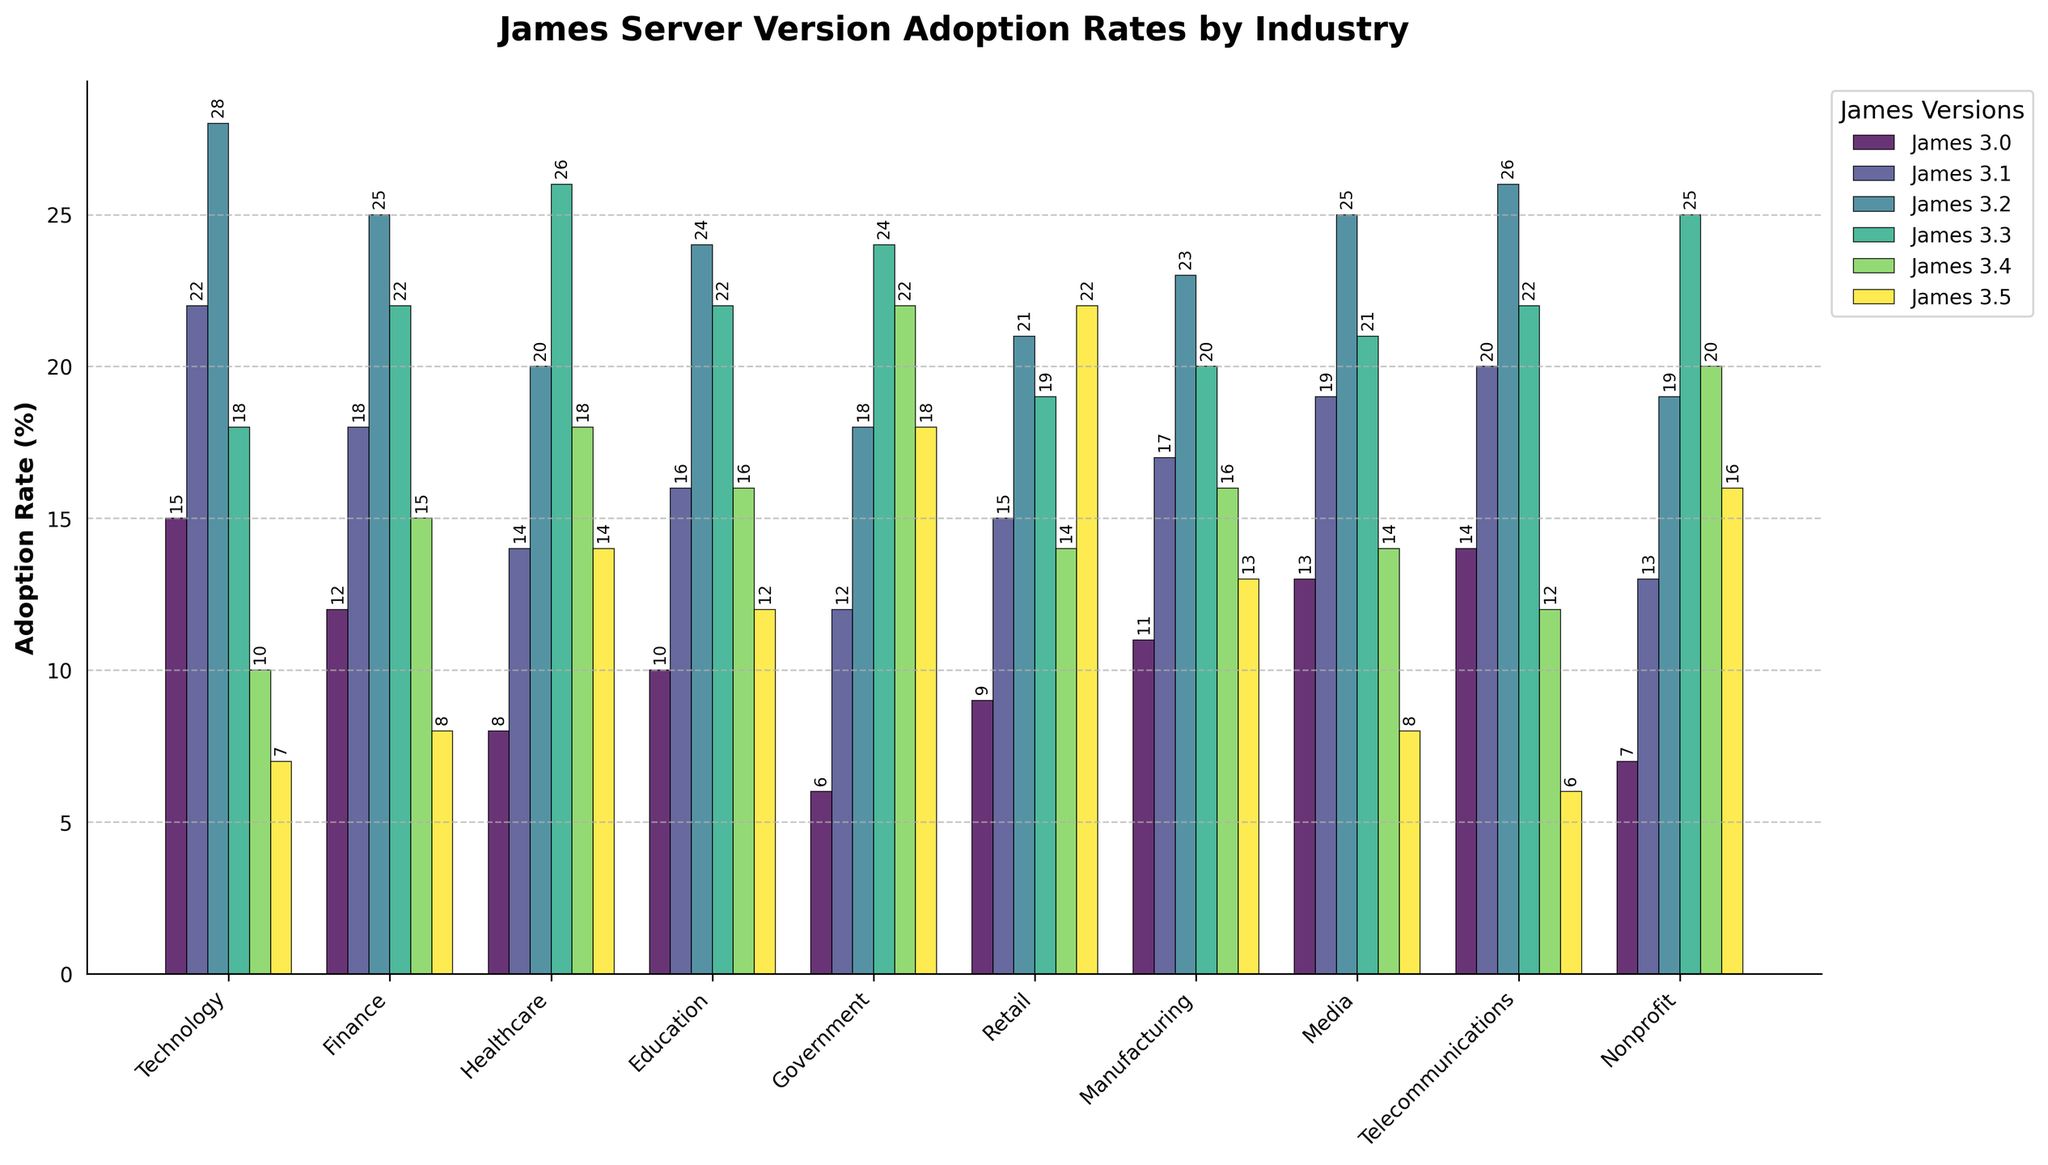Which industry has the highest adoption rate for James 3.2? Look for the highest bar in the group corresponding to James 3.2 and note the industry label beneath it.
Answer: Media What's the difference in the adoption rates of James 3.0 and James 3.4 in the Healthcare sector? Look at the bar heights for James 3.0 and James 3.4 in the Healthcare sector and calculate the difference: 18 - 8.
Answer: 10 Which two industries have the most similar adoption rates for James 3.1? Compare the heights of the bars for James 3.1 across all industries and identify the two closest values: Technology (22) and Telecommunications (20).
Answer: Technology and Telecommunications What is the average adoption rate of James 3.3 across all industries? Sum the adoption rates of James 3.3 across all industries and divide by the number of industries: (18 + 22 + 26 + 22 + 24 + 19 + 20 + 21 + 22 + 25) / 10.
Answer: 21.9 Is the adoption rate of James 3.5 in the Education sector higher or lower than in the Government sector? Compare the bar heights for James 3.5 in Education (12) and Government (18).
Answer: Lower How many industries have an adoption rate of 20% or higher for James 3.4? Count the number of bars for James 3.4 which are 20 or higher: Government (22), Nonprofit (20), Healthcare (18), Retail (14). Only Government and Nonprofit meet the criteria.
Answer: 2 Which version has the greatest range in adoption rates across all industries? Calculate the range (max - min) for each version and identify the highest: James 3.0: 15 - 6 = 9, James 3.1: 22 - 12 = 10, James 3.2: 28 - 18 = 10, James 3.3: 26 - 18 = 8, James 3.4: 22 - 10 = 12, James 3.5: 22 - 6 = 16.
Answer: James 3.5 What's the sum of the adoption rates for James 3.0 and James 3.3 in the Technology sector? Add the adoption rates for James 3.0 and James 3.3 in the Technology sector: 15 + 18.
Answer: 33 Which industry has the lowest adoption rate for James 3.1 and what is the rate? Look for the shortest bar in the group corresponding to James 3.1 and note the industry label and value: Government (12).
Answer: Government, 12 